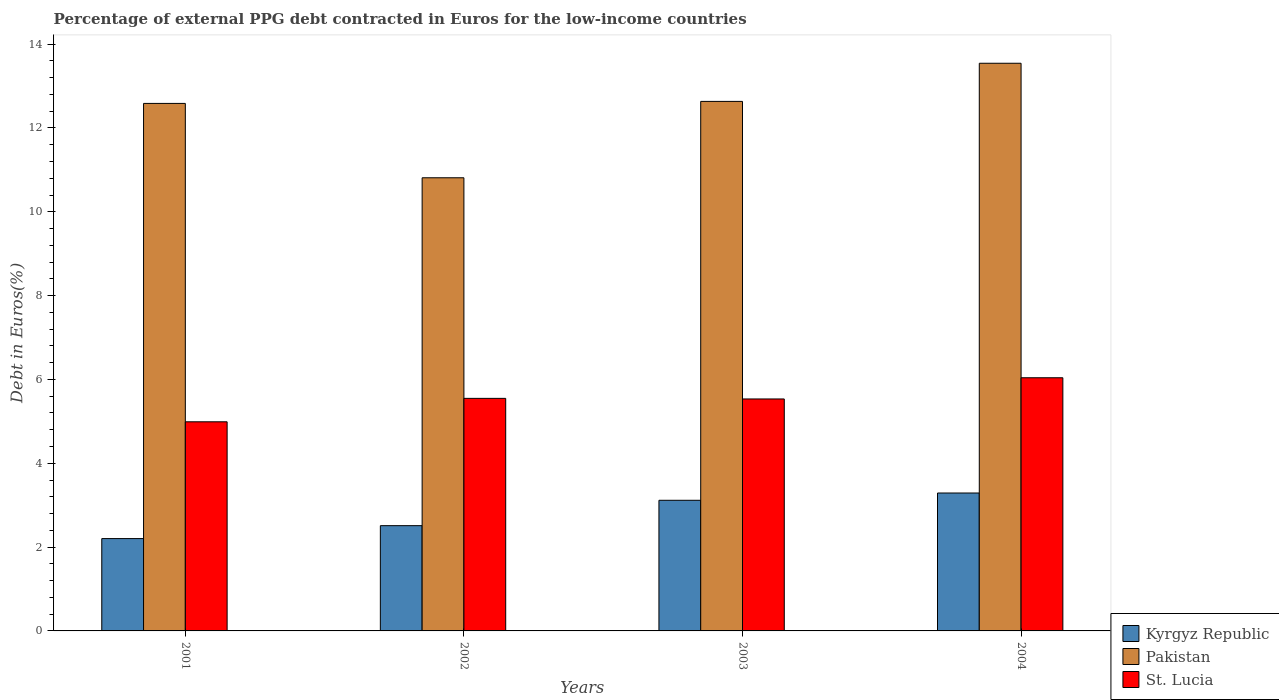How many different coloured bars are there?
Offer a terse response. 3. How many groups of bars are there?
Ensure brevity in your answer.  4. How many bars are there on the 2nd tick from the right?
Keep it short and to the point. 3. What is the percentage of external PPG debt contracted in Euros in St. Lucia in 2002?
Make the answer very short. 5.55. Across all years, what is the maximum percentage of external PPG debt contracted in Euros in Kyrgyz Republic?
Make the answer very short. 3.29. Across all years, what is the minimum percentage of external PPG debt contracted in Euros in Pakistan?
Offer a terse response. 10.81. In which year was the percentage of external PPG debt contracted in Euros in Kyrgyz Republic maximum?
Make the answer very short. 2004. What is the total percentage of external PPG debt contracted in Euros in Pakistan in the graph?
Your answer should be very brief. 49.58. What is the difference between the percentage of external PPG debt contracted in Euros in Pakistan in 2003 and that in 2004?
Offer a very short reply. -0.91. What is the difference between the percentage of external PPG debt contracted in Euros in Kyrgyz Republic in 2002 and the percentage of external PPG debt contracted in Euros in St. Lucia in 2004?
Provide a short and direct response. -3.53. What is the average percentage of external PPG debt contracted in Euros in Pakistan per year?
Offer a very short reply. 12.39. In the year 2003, what is the difference between the percentage of external PPG debt contracted in Euros in Kyrgyz Republic and percentage of external PPG debt contracted in Euros in Pakistan?
Give a very brief answer. -9.52. In how many years, is the percentage of external PPG debt contracted in Euros in St. Lucia greater than 10 %?
Your response must be concise. 0. What is the ratio of the percentage of external PPG debt contracted in Euros in St. Lucia in 2002 to that in 2004?
Give a very brief answer. 0.92. What is the difference between the highest and the second highest percentage of external PPG debt contracted in Euros in Kyrgyz Republic?
Offer a terse response. 0.17. What is the difference between the highest and the lowest percentage of external PPG debt contracted in Euros in St. Lucia?
Make the answer very short. 1.05. What does the 1st bar from the right in 2003 represents?
Make the answer very short. St. Lucia. Is it the case that in every year, the sum of the percentage of external PPG debt contracted in Euros in St. Lucia and percentage of external PPG debt contracted in Euros in Kyrgyz Republic is greater than the percentage of external PPG debt contracted in Euros in Pakistan?
Give a very brief answer. No. Are all the bars in the graph horizontal?
Offer a terse response. No. How many years are there in the graph?
Offer a very short reply. 4. What is the difference between two consecutive major ticks on the Y-axis?
Offer a very short reply. 2. How are the legend labels stacked?
Your answer should be compact. Vertical. What is the title of the graph?
Offer a terse response. Percentage of external PPG debt contracted in Euros for the low-income countries. What is the label or title of the Y-axis?
Your answer should be very brief. Debt in Euros(%). What is the Debt in Euros(%) of Kyrgyz Republic in 2001?
Offer a very short reply. 2.2. What is the Debt in Euros(%) of Pakistan in 2001?
Offer a very short reply. 12.59. What is the Debt in Euros(%) in St. Lucia in 2001?
Your answer should be compact. 4.99. What is the Debt in Euros(%) of Kyrgyz Republic in 2002?
Make the answer very short. 2.51. What is the Debt in Euros(%) in Pakistan in 2002?
Your answer should be very brief. 10.81. What is the Debt in Euros(%) in St. Lucia in 2002?
Offer a very short reply. 5.55. What is the Debt in Euros(%) of Kyrgyz Republic in 2003?
Make the answer very short. 3.12. What is the Debt in Euros(%) of Pakistan in 2003?
Offer a very short reply. 12.63. What is the Debt in Euros(%) in St. Lucia in 2003?
Keep it short and to the point. 5.53. What is the Debt in Euros(%) in Kyrgyz Republic in 2004?
Your answer should be compact. 3.29. What is the Debt in Euros(%) of Pakistan in 2004?
Give a very brief answer. 13.54. What is the Debt in Euros(%) of St. Lucia in 2004?
Provide a succinct answer. 6.04. Across all years, what is the maximum Debt in Euros(%) in Kyrgyz Republic?
Provide a succinct answer. 3.29. Across all years, what is the maximum Debt in Euros(%) of Pakistan?
Ensure brevity in your answer.  13.54. Across all years, what is the maximum Debt in Euros(%) in St. Lucia?
Your answer should be very brief. 6.04. Across all years, what is the minimum Debt in Euros(%) in Kyrgyz Republic?
Keep it short and to the point. 2.2. Across all years, what is the minimum Debt in Euros(%) in Pakistan?
Give a very brief answer. 10.81. Across all years, what is the minimum Debt in Euros(%) of St. Lucia?
Provide a succinct answer. 4.99. What is the total Debt in Euros(%) in Kyrgyz Republic in the graph?
Provide a short and direct response. 11.12. What is the total Debt in Euros(%) in Pakistan in the graph?
Your response must be concise. 49.58. What is the total Debt in Euros(%) in St. Lucia in the graph?
Provide a succinct answer. 22.11. What is the difference between the Debt in Euros(%) of Kyrgyz Republic in 2001 and that in 2002?
Your answer should be compact. -0.31. What is the difference between the Debt in Euros(%) of Pakistan in 2001 and that in 2002?
Your answer should be compact. 1.77. What is the difference between the Debt in Euros(%) in St. Lucia in 2001 and that in 2002?
Offer a terse response. -0.56. What is the difference between the Debt in Euros(%) of Kyrgyz Republic in 2001 and that in 2003?
Offer a very short reply. -0.91. What is the difference between the Debt in Euros(%) in Pakistan in 2001 and that in 2003?
Provide a short and direct response. -0.05. What is the difference between the Debt in Euros(%) in St. Lucia in 2001 and that in 2003?
Ensure brevity in your answer.  -0.54. What is the difference between the Debt in Euros(%) of Kyrgyz Republic in 2001 and that in 2004?
Give a very brief answer. -1.09. What is the difference between the Debt in Euros(%) of Pakistan in 2001 and that in 2004?
Ensure brevity in your answer.  -0.96. What is the difference between the Debt in Euros(%) in St. Lucia in 2001 and that in 2004?
Offer a terse response. -1.05. What is the difference between the Debt in Euros(%) of Kyrgyz Republic in 2002 and that in 2003?
Provide a short and direct response. -0.61. What is the difference between the Debt in Euros(%) in Pakistan in 2002 and that in 2003?
Give a very brief answer. -1.82. What is the difference between the Debt in Euros(%) of St. Lucia in 2002 and that in 2003?
Provide a succinct answer. 0.01. What is the difference between the Debt in Euros(%) of Kyrgyz Republic in 2002 and that in 2004?
Offer a very short reply. -0.78. What is the difference between the Debt in Euros(%) in Pakistan in 2002 and that in 2004?
Your response must be concise. -2.73. What is the difference between the Debt in Euros(%) in St. Lucia in 2002 and that in 2004?
Offer a very short reply. -0.49. What is the difference between the Debt in Euros(%) in Kyrgyz Republic in 2003 and that in 2004?
Give a very brief answer. -0.17. What is the difference between the Debt in Euros(%) in Pakistan in 2003 and that in 2004?
Make the answer very short. -0.91. What is the difference between the Debt in Euros(%) in St. Lucia in 2003 and that in 2004?
Make the answer very short. -0.51. What is the difference between the Debt in Euros(%) of Kyrgyz Republic in 2001 and the Debt in Euros(%) of Pakistan in 2002?
Provide a short and direct response. -8.61. What is the difference between the Debt in Euros(%) in Kyrgyz Republic in 2001 and the Debt in Euros(%) in St. Lucia in 2002?
Offer a very short reply. -3.35. What is the difference between the Debt in Euros(%) in Pakistan in 2001 and the Debt in Euros(%) in St. Lucia in 2002?
Offer a terse response. 7.04. What is the difference between the Debt in Euros(%) of Kyrgyz Republic in 2001 and the Debt in Euros(%) of Pakistan in 2003?
Provide a succinct answer. -10.43. What is the difference between the Debt in Euros(%) in Kyrgyz Republic in 2001 and the Debt in Euros(%) in St. Lucia in 2003?
Keep it short and to the point. -3.33. What is the difference between the Debt in Euros(%) of Pakistan in 2001 and the Debt in Euros(%) of St. Lucia in 2003?
Give a very brief answer. 7.05. What is the difference between the Debt in Euros(%) in Kyrgyz Republic in 2001 and the Debt in Euros(%) in Pakistan in 2004?
Make the answer very short. -11.34. What is the difference between the Debt in Euros(%) of Kyrgyz Republic in 2001 and the Debt in Euros(%) of St. Lucia in 2004?
Your answer should be compact. -3.84. What is the difference between the Debt in Euros(%) of Pakistan in 2001 and the Debt in Euros(%) of St. Lucia in 2004?
Your response must be concise. 6.55. What is the difference between the Debt in Euros(%) in Kyrgyz Republic in 2002 and the Debt in Euros(%) in Pakistan in 2003?
Your response must be concise. -10.12. What is the difference between the Debt in Euros(%) of Kyrgyz Republic in 2002 and the Debt in Euros(%) of St. Lucia in 2003?
Provide a succinct answer. -3.02. What is the difference between the Debt in Euros(%) of Pakistan in 2002 and the Debt in Euros(%) of St. Lucia in 2003?
Make the answer very short. 5.28. What is the difference between the Debt in Euros(%) of Kyrgyz Republic in 2002 and the Debt in Euros(%) of Pakistan in 2004?
Your response must be concise. -11.03. What is the difference between the Debt in Euros(%) in Kyrgyz Republic in 2002 and the Debt in Euros(%) in St. Lucia in 2004?
Ensure brevity in your answer.  -3.53. What is the difference between the Debt in Euros(%) in Pakistan in 2002 and the Debt in Euros(%) in St. Lucia in 2004?
Your response must be concise. 4.77. What is the difference between the Debt in Euros(%) of Kyrgyz Republic in 2003 and the Debt in Euros(%) of Pakistan in 2004?
Your response must be concise. -10.43. What is the difference between the Debt in Euros(%) in Kyrgyz Republic in 2003 and the Debt in Euros(%) in St. Lucia in 2004?
Your answer should be compact. -2.92. What is the difference between the Debt in Euros(%) of Pakistan in 2003 and the Debt in Euros(%) of St. Lucia in 2004?
Offer a very short reply. 6.59. What is the average Debt in Euros(%) in Kyrgyz Republic per year?
Your answer should be very brief. 2.78. What is the average Debt in Euros(%) of Pakistan per year?
Give a very brief answer. 12.39. What is the average Debt in Euros(%) in St. Lucia per year?
Your answer should be compact. 5.53. In the year 2001, what is the difference between the Debt in Euros(%) of Kyrgyz Republic and Debt in Euros(%) of Pakistan?
Provide a short and direct response. -10.38. In the year 2001, what is the difference between the Debt in Euros(%) in Kyrgyz Republic and Debt in Euros(%) in St. Lucia?
Give a very brief answer. -2.79. In the year 2001, what is the difference between the Debt in Euros(%) in Pakistan and Debt in Euros(%) in St. Lucia?
Your response must be concise. 7.6. In the year 2002, what is the difference between the Debt in Euros(%) of Kyrgyz Republic and Debt in Euros(%) of Pakistan?
Your response must be concise. -8.3. In the year 2002, what is the difference between the Debt in Euros(%) in Kyrgyz Republic and Debt in Euros(%) in St. Lucia?
Your answer should be compact. -3.04. In the year 2002, what is the difference between the Debt in Euros(%) of Pakistan and Debt in Euros(%) of St. Lucia?
Ensure brevity in your answer.  5.26. In the year 2003, what is the difference between the Debt in Euros(%) of Kyrgyz Republic and Debt in Euros(%) of Pakistan?
Offer a terse response. -9.52. In the year 2003, what is the difference between the Debt in Euros(%) of Kyrgyz Republic and Debt in Euros(%) of St. Lucia?
Ensure brevity in your answer.  -2.42. In the year 2003, what is the difference between the Debt in Euros(%) of Pakistan and Debt in Euros(%) of St. Lucia?
Ensure brevity in your answer.  7.1. In the year 2004, what is the difference between the Debt in Euros(%) of Kyrgyz Republic and Debt in Euros(%) of Pakistan?
Your answer should be very brief. -10.25. In the year 2004, what is the difference between the Debt in Euros(%) of Kyrgyz Republic and Debt in Euros(%) of St. Lucia?
Offer a very short reply. -2.75. In the year 2004, what is the difference between the Debt in Euros(%) of Pakistan and Debt in Euros(%) of St. Lucia?
Provide a short and direct response. 7.5. What is the ratio of the Debt in Euros(%) of Kyrgyz Republic in 2001 to that in 2002?
Provide a short and direct response. 0.88. What is the ratio of the Debt in Euros(%) in Pakistan in 2001 to that in 2002?
Keep it short and to the point. 1.16. What is the ratio of the Debt in Euros(%) in St. Lucia in 2001 to that in 2002?
Your response must be concise. 0.9. What is the ratio of the Debt in Euros(%) of Kyrgyz Republic in 2001 to that in 2003?
Offer a very short reply. 0.71. What is the ratio of the Debt in Euros(%) in Pakistan in 2001 to that in 2003?
Offer a very short reply. 1. What is the ratio of the Debt in Euros(%) of St. Lucia in 2001 to that in 2003?
Ensure brevity in your answer.  0.9. What is the ratio of the Debt in Euros(%) in Kyrgyz Republic in 2001 to that in 2004?
Offer a very short reply. 0.67. What is the ratio of the Debt in Euros(%) of Pakistan in 2001 to that in 2004?
Provide a short and direct response. 0.93. What is the ratio of the Debt in Euros(%) of St. Lucia in 2001 to that in 2004?
Your answer should be very brief. 0.83. What is the ratio of the Debt in Euros(%) in Kyrgyz Republic in 2002 to that in 2003?
Make the answer very short. 0.81. What is the ratio of the Debt in Euros(%) of Pakistan in 2002 to that in 2003?
Offer a very short reply. 0.86. What is the ratio of the Debt in Euros(%) of Kyrgyz Republic in 2002 to that in 2004?
Offer a terse response. 0.76. What is the ratio of the Debt in Euros(%) of Pakistan in 2002 to that in 2004?
Ensure brevity in your answer.  0.8. What is the ratio of the Debt in Euros(%) of St. Lucia in 2002 to that in 2004?
Provide a short and direct response. 0.92. What is the ratio of the Debt in Euros(%) in Kyrgyz Republic in 2003 to that in 2004?
Provide a succinct answer. 0.95. What is the ratio of the Debt in Euros(%) of Pakistan in 2003 to that in 2004?
Offer a very short reply. 0.93. What is the ratio of the Debt in Euros(%) of St. Lucia in 2003 to that in 2004?
Keep it short and to the point. 0.92. What is the difference between the highest and the second highest Debt in Euros(%) in Kyrgyz Republic?
Offer a terse response. 0.17. What is the difference between the highest and the second highest Debt in Euros(%) in Pakistan?
Ensure brevity in your answer.  0.91. What is the difference between the highest and the second highest Debt in Euros(%) of St. Lucia?
Make the answer very short. 0.49. What is the difference between the highest and the lowest Debt in Euros(%) of Kyrgyz Republic?
Offer a very short reply. 1.09. What is the difference between the highest and the lowest Debt in Euros(%) of Pakistan?
Make the answer very short. 2.73. What is the difference between the highest and the lowest Debt in Euros(%) of St. Lucia?
Keep it short and to the point. 1.05. 